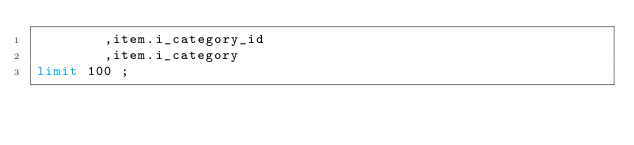Convert code to text. <code><loc_0><loc_0><loc_500><loc_500><_SQL_> 		,item.i_category_id
 		,item.i_category
limit 100 ;


</code> 